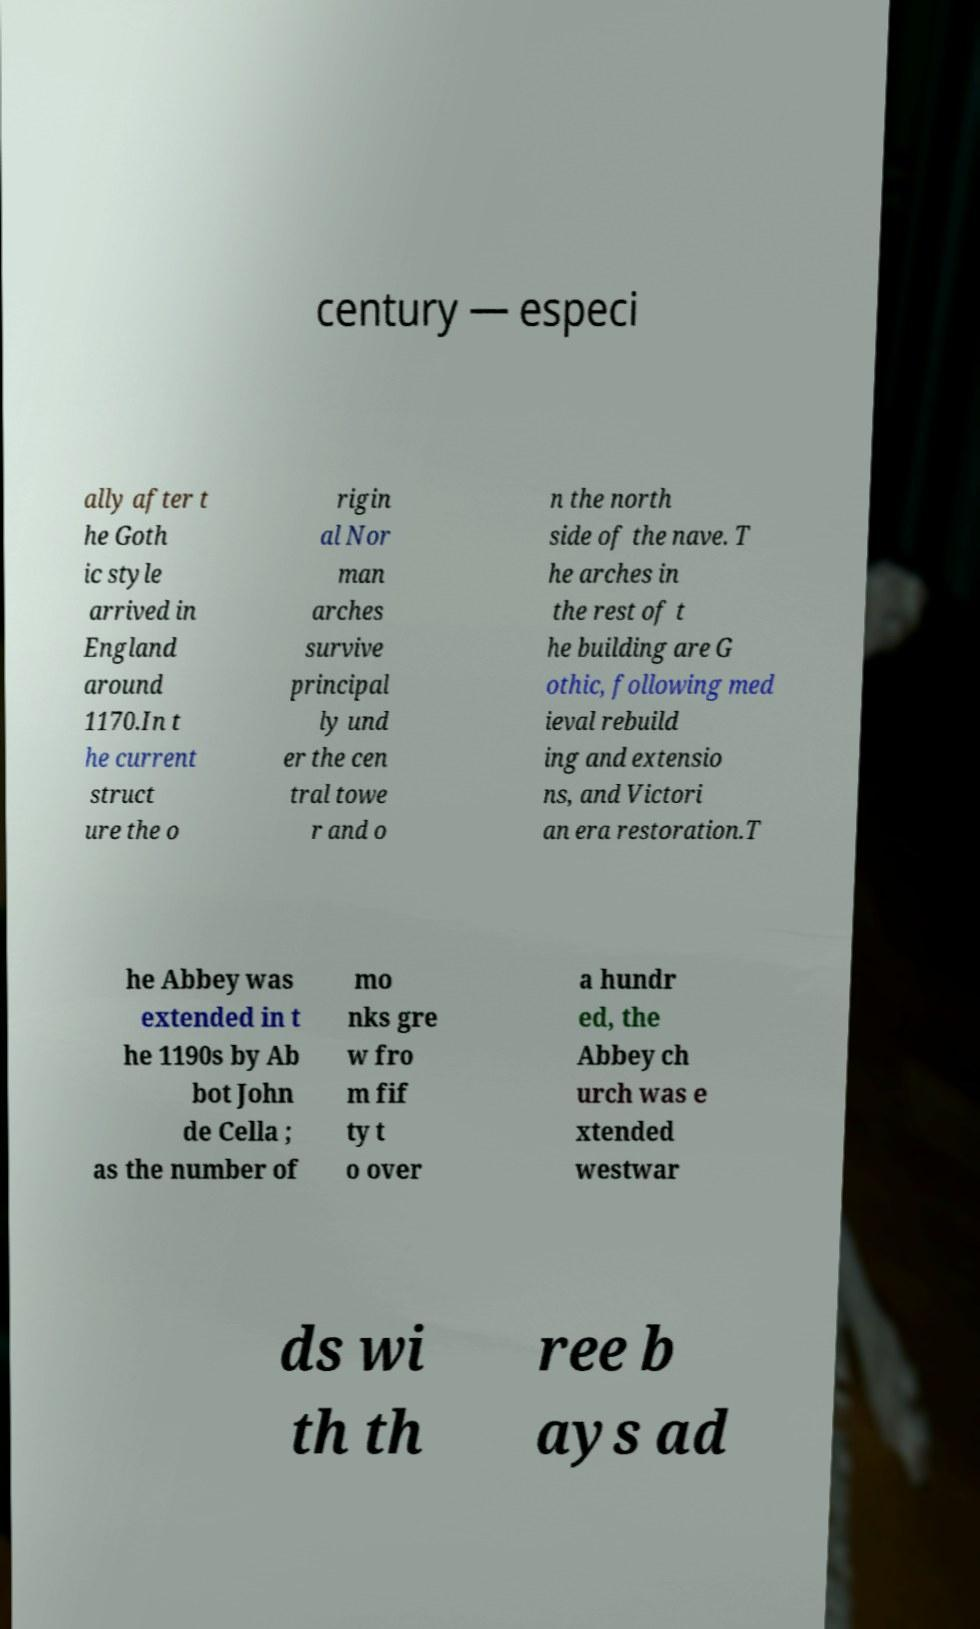There's text embedded in this image that I need extracted. Can you transcribe it verbatim? century — especi ally after t he Goth ic style arrived in England around 1170.In t he current struct ure the o rigin al Nor man arches survive principal ly und er the cen tral towe r and o n the north side of the nave. T he arches in the rest of t he building are G othic, following med ieval rebuild ing and extensio ns, and Victori an era restoration.T he Abbey was extended in t he 1190s by Ab bot John de Cella ; as the number of mo nks gre w fro m fif ty t o over a hundr ed, the Abbey ch urch was e xtended westwar ds wi th th ree b ays ad 